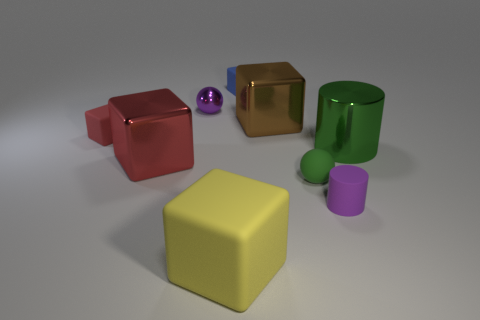Can you describe the colors of the objects in the image? Certainly! In the image, we see objects in various colors: there's a red cube, a purple sphere, a blue cube, a green cylinder, a pink cylinder, a shiny gold cube, and a yellow cube. Which objects are reflective or shiny? The objects that appear reflective or shiny are the purple sphere, the green cylinder, and the gold cube. They seem to have a glossy finish that quite starkly contrasts with the matte finish of the other objects. 